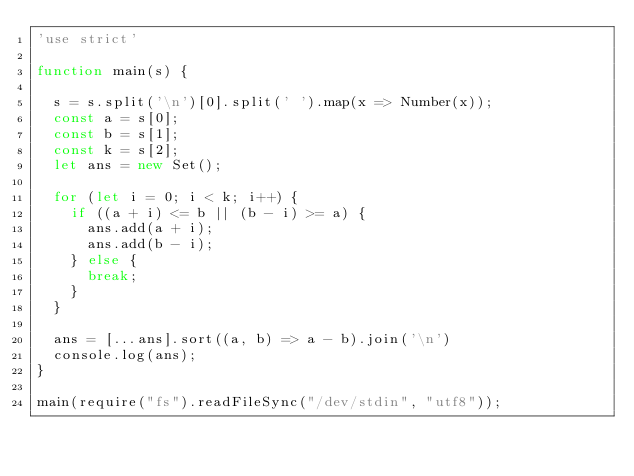Convert code to text. <code><loc_0><loc_0><loc_500><loc_500><_JavaScript_>'use strict'

function main(s) {

  s = s.split('\n')[0].split(' ').map(x => Number(x));
  const a = s[0];
  const b = s[1];
  const k = s[2];
  let ans = new Set();

  for (let i = 0; i < k; i++) {
    if ((a + i) <= b || (b - i) >= a) {
      ans.add(a + i);
      ans.add(b - i);
    } else {
      break;
    }
  }

  ans = [...ans].sort((a, b) => a - b).join('\n')
  console.log(ans);
}

main(require("fs").readFileSync("/dev/stdin", "utf8"));
</code> 